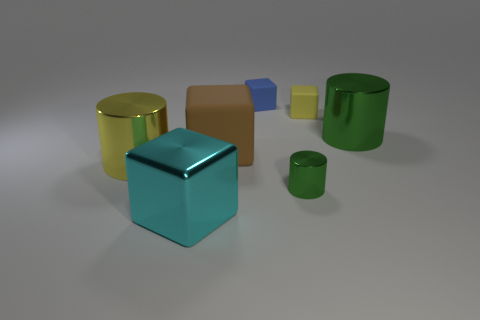Add 1 tiny green things. How many objects exist? 8 Subtract all blocks. How many objects are left? 3 Subtract all small blue rubber objects. Subtract all cylinders. How many objects are left? 3 Add 2 cubes. How many cubes are left? 6 Add 6 large green rubber blocks. How many large green rubber blocks exist? 6 Subtract 0 red balls. How many objects are left? 7 